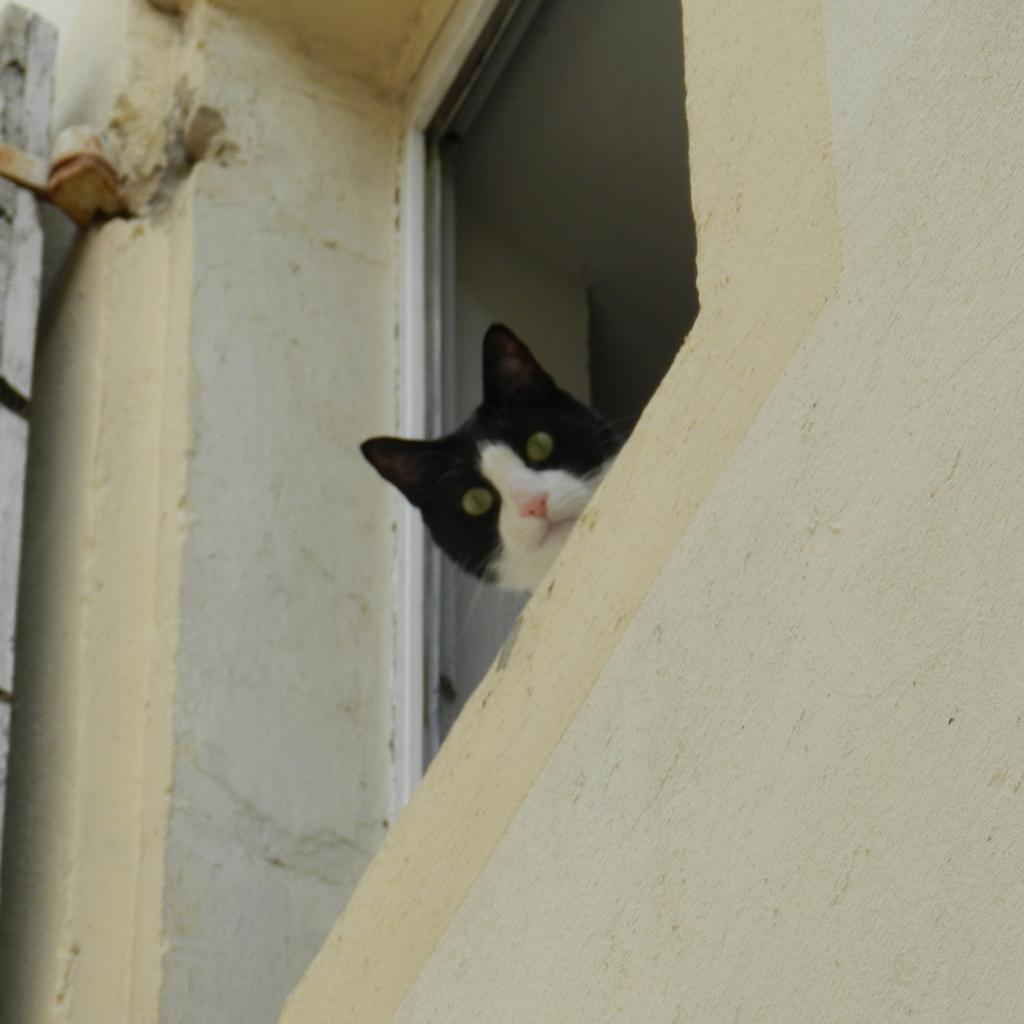What type of animal is in the picture? There is a cat in the picture. What colors can be seen on the cat? The cat is black and white in color. Can you describe any other objects in the picture? Unfortunately, the specific details of other objects in the picture are not mentioned in the provided facts. What type of harmony is the cat trying to achieve with the need in the image? There is no mention of a need or harmony in the image, as the provided facts only mention the presence of a cat and its color. 